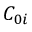<formula> <loc_0><loc_0><loc_500><loc_500>C _ { 0 i }</formula> 